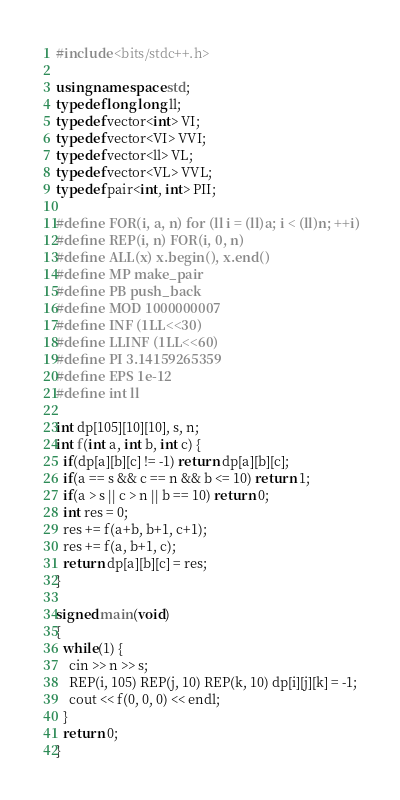Convert code to text. <code><loc_0><loc_0><loc_500><loc_500><_C++_>#include <bits/stdc++.h>

using namespace std;
typedef long long ll;
typedef vector<int> VI;
typedef vector<VI> VVI;
typedef vector<ll> VL;
typedef vector<VL> VVL;
typedef pair<int, int> PII;

#define FOR(i, a, n) for (ll i = (ll)a; i < (ll)n; ++i)
#define REP(i, n) FOR(i, 0, n)
#define ALL(x) x.begin(), x.end()
#define MP make_pair
#define PB push_back
#define MOD 1000000007
#define INF (1LL<<30)
#define LLINF (1LL<<60)
#define PI 3.14159265359
#define EPS 1e-12
#define int ll

int dp[105][10][10], s, n;
int f(int a, int b, int c) {
  if(dp[a][b][c] != -1) return dp[a][b][c];
  if(a == s && c == n && b <= 10) return 1;
  if(a > s || c > n || b == 10) return 0;
  int res = 0;
  res += f(a+b, b+1, c+1);
  res += f(a, b+1, c);
  return dp[a][b][c] = res;
}

signed main(void)
{
  while(1) {
    cin >> n >> s;
    REP(i, 105) REP(j, 10) REP(k, 10) dp[i][j][k] = -1;
    cout << f(0, 0, 0) << endl;
  }
  return 0;
}</code> 